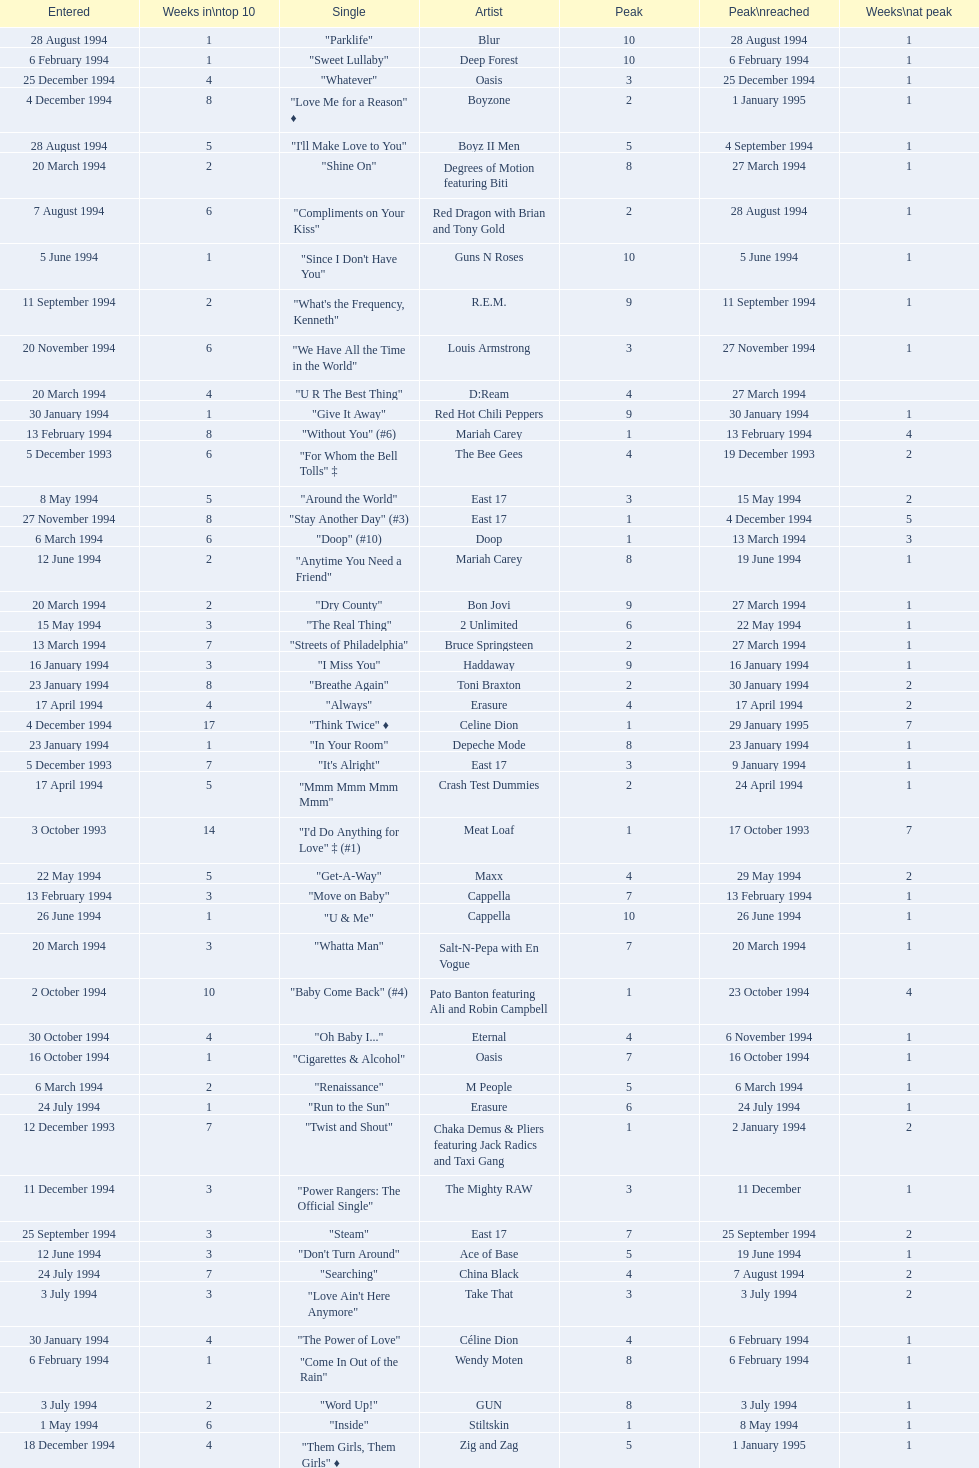Can you give me this table as a dict? {'header': ['Entered', 'Weeks in\\ntop 10', 'Single', 'Artist', 'Peak', 'Peak\\nreached', 'Weeks\\nat peak'], 'rows': [['28 August 1994', '1', '"Parklife"', 'Blur', '10', '28 August 1994', '1'], ['6 February 1994', '1', '"Sweet Lullaby"', 'Deep Forest', '10', '6 February 1994', '1'], ['25 December 1994', '4', '"Whatever"', 'Oasis', '3', '25 December 1994', '1'], ['4 December 1994', '8', '"Love Me for a Reason" ♦', 'Boyzone', '2', '1 January 1995', '1'], ['28 August 1994', '5', '"I\'ll Make Love to You"', 'Boyz II Men', '5', '4 September 1994', '1'], ['20 March 1994', '2', '"Shine On"', 'Degrees of Motion featuring Biti', '8', '27 March 1994', '1'], ['7 August 1994', '6', '"Compliments on Your Kiss"', 'Red Dragon with Brian and Tony Gold', '2', '28 August 1994', '1'], ['5 June 1994', '1', '"Since I Don\'t Have You"', 'Guns N Roses', '10', '5 June 1994', '1'], ['11 September 1994', '2', '"What\'s the Frequency, Kenneth"', 'R.E.M.', '9', '11 September 1994', '1'], ['20 November 1994', '6', '"We Have All the Time in the World"', 'Louis Armstrong', '3', '27 November 1994', '1'], ['20 March 1994', '4', '"U R The Best Thing"', 'D:Ream', '4', '27 March 1994', ''], ['30 January 1994', '1', '"Give It Away"', 'Red Hot Chili Peppers', '9', '30 January 1994', '1'], ['13 February 1994', '8', '"Without You" (#6)', 'Mariah Carey', '1', '13 February 1994', '4'], ['5 December 1993', '6', '"For Whom the Bell Tolls" ‡', 'The Bee Gees', '4', '19 December 1993', '2'], ['8 May 1994', '5', '"Around the World"', 'East 17', '3', '15 May 1994', '2'], ['27 November 1994', '8', '"Stay Another Day" (#3)', 'East 17', '1', '4 December 1994', '5'], ['6 March 1994', '6', '"Doop" (#10)', 'Doop', '1', '13 March 1994', '3'], ['12 June 1994', '2', '"Anytime You Need a Friend"', 'Mariah Carey', '8', '19 June 1994', '1'], ['20 March 1994', '2', '"Dry County"', 'Bon Jovi', '9', '27 March 1994', '1'], ['15 May 1994', '3', '"The Real Thing"', '2 Unlimited', '6', '22 May 1994', '1'], ['13 March 1994', '7', '"Streets of Philadelphia"', 'Bruce Springsteen', '2', '27 March 1994', '1'], ['16 January 1994', '3', '"I Miss You"', 'Haddaway', '9', '16 January 1994', '1'], ['23 January 1994', '8', '"Breathe Again"', 'Toni Braxton', '2', '30 January 1994', '2'], ['17 April 1994', '4', '"Always"', 'Erasure', '4', '17 April 1994', '2'], ['4 December 1994', '17', '"Think Twice" ♦', 'Celine Dion', '1', '29 January 1995', '7'], ['23 January 1994', '1', '"In Your Room"', 'Depeche Mode', '8', '23 January 1994', '1'], ['5 December 1993', '7', '"It\'s Alright"', 'East 17', '3', '9 January 1994', '1'], ['17 April 1994', '5', '"Mmm Mmm Mmm Mmm"', 'Crash Test Dummies', '2', '24 April 1994', '1'], ['3 October 1993', '14', '"I\'d Do Anything for Love" ‡ (#1)', 'Meat Loaf', '1', '17 October 1993', '7'], ['22 May 1994', '5', '"Get-A-Way"', 'Maxx', '4', '29 May 1994', '2'], ['13 February 1994', '3', '"Move on Baby"', 'Cappella', '7', '13 February 1994', '1'], ['26 June 1994', '1', '"U & Me"', 'Cappella', '10', '26 June 1994', '1'], ['20 March 1994', '3', '"Whatta Man"', 'Salt-N-Pepa with En Vogue', '7', '20 March 1994', '1'], ['2 October 1994', '10', '"Baby Come Back" (#4)', 'Pato Banton featuring Ali and Robin Campbell', '1', '23 October 1994', '4'], ['30 October 1994', '4', '"Oh Baby I..."', 'Eternal', '4', '6 November 1994', '1'], ['16 October 1994', '1', '"Cigarettes & Alcohol"', 'Oasis', '7', '16 October 1994', '1'], ['6 March 1994', '2', '"Renaissance"', 'M People', '5', '6 March 1994', '1'], ['24 July 1994', '1', '"Run to the Sun"', 'Erasure', '6', '24 July 1994', '1'], ['12 December 1993', '7', '"Twist and Shout"', 'Chaka Demus & Pliers featuring Jack Radics and Taxi Gang', '1', '2 January 1994', '2'], ['11 December 1994', '3', '"Power Rangers: The Official Single"', 'The Mighty RAW', '3', '11 December', '1'], ['25 September 1994', '3', '"Steam"', 'East 17', '7', '25 September 1994', '2'], ['12 June 1994', '3', '"Don\'t Turn Around"', 'Ace of Base', '5', '19 June 1994', '1'], ['24 July 1994', '7', '"Searching"', 'China Black', '4', '7 August 1994', '2'], ['3 July 1994', '3', '"Love Ain\'t Here Anymore"', 'Take That', '3', '3 July 1994', '2'], ['30 January 1994', '4', '"The Power of Love"', 'Céline Dion', '4', '6 February 1994', '1'], ['6 February 1994', '1', '"Come In Out of the Rain"', 'Wendy Moten', '8', '6 February 1994', '1'], ['3 July 1994', '2', '"Word Up!"', 'GUN', '8', '3 July 1994', '1'], ['1 May 1994', '6', '"Inside"', 'Stiltskin', '1', '8 May 1994', '1'], ['18 December 1994', '4', '"Them Girls, Them Girls" ♦', 'Zig and Zag', '5', '1 January 1995', '1'], ['16 October 1994', '4', '"Welcome to Tomorrow (Are You Ready?)"', 'Snap! featuring Summer', '6', '30 October 1994', '1'], ['10 July 1994', '9', '"Crazy for You" (#8)', 'Let Loose', '2', '14 August 1994', '2'], ['30 October 1994', '2', '"Some Girls"', 'Ultimate Kaos', '9', '30 October 1994', '1'], ['17 July 1994', '8', '"Regulate"', 'Warren G and Nate Dogg', '5', '24 July 1994', '1'], ['27 November 1994', '2', '"Love Spreads"', 'The Stone Roses', '2', '27 November 1994', '1'], ['12 December 1993', '5', '"The Perfect Year"', 'Dina Carroll', '5', '2 January 1994', '1'], ['18 December 1994', '10', '"Cotton Eye Joe" ♦', 'Rednex', '1', '8 January 1995', '3'], ['12 December 1993', '5', '"Babe" ‡', 'Take That', '1', '12 December 1993', '1'], ['28 November 1993', '7', '"Mr Blobby" ‡ (#6)', 'Mr Blobby', '1', '5 December 1993', '3'], ['31 July 1994', '4', '"Let\'s Get Ready to Rhumble"', 'PJ & Duncan', '1', '31 March 2013', '1'], ['16 October 1994', '5', '"She\'s Got That Vibe"', 'R. Kelly', '3', '6 November 1994', '1'], ['17 July 1994', '2', '"Everything is Alright (Uptight)"', 'C.J. Lewis', '10', '17 July 1994', '2'], ['5 June 1994', '3', '"Absolutely Fabulous"', 'Absolutely Fabulous', '6', '12 June 1994', '1'], ['9 January 1994', '4', '"Anything"', 'Culture Beat', '5', '9 January 1994', '2'], ['2 October 1994', '6', '"Sweetness"', 'Michelle Gayle', '4', '30 October 1994', '1'], ['27 February 1994', '1', '"Don\'t Go Breaking My Heart"', 'Elton John and RuPaul', '7', '27 February 1994', '1'], ['6 February 1994', '11', '"I Like to Move It"', 'Reel 2 Real featuring The Mad Stuntman', '5', '27 March 1994', '1'], ['13 March 1994', '1', '"Pretty Good Year"', 'Tori Amos', '7', '13 March 1994', '1'], ['2 October 1994', '2', '"Secret"', 'Madonna', '5', '2 October 1994', '1'], ['6 November 1994', '4', '"All I Wanna Do"', 'Sheryl Crow', '4', '20 November 1994', '1'], ['21 August 1994', '1', '"Eighteen Strings"', 'Tinman', '9', '21 August 1994', '1'], ['11 September 1994', '4', '"Endless Love"', 'Luther Vandross and Mariah Carey', '3', '11 September 1994', '2'], ['2 January 1994', '9', '"Things Can Only Get Better" (#9)', 'D:Ream', '1', '16 January 1994', '4'], ['24 April 1994', '1', '"I\'ll Stand by You"', 'The Pretenders', '10', '24 April 1994', '1'], ['20 February 1994', '9', '"The Sign"', 'Ace of Base', '2', '27 February 1994', '3'], ['11 December 1994', '2', '"Another Day" ♦', 'Whigfield', '7', '1 January 1995', '1'], ['18 September 1994', '11', '"Always" (#7)', 'Bon Jovi', '2', '2 October 1994', '3'], ['11 September 1994', '3', '"Incredible"', 'M-Beat featuring General Levy', '8', '18 September 1994', '1'], ['6 February 1994', '2', '"A Deeper Love"', 'Aretha Franklin featuring Lisa Fischer', '5', '6 February 1994', '1'], ['1 May 1994', '2', '"Light My Fire"', 'Clubhouse featuring Carl', '7', '1 May 1994', '1'], ['23 October 1994', '1', '"When We Dance"', 'Sting', '9', '23 October 1994', '1'], ['23 January 1994', '8', '"Return to Innocence"', 'Enigma', '3', '6 February 1994', '2'], ['20 February 1994', '2', '"Stay Together"', 'Suede', '3', '20 February 1994', '1'], ['12 June 1994', '8', '"Swamp Thing"', 'The Grid', '3', '26 June 1994', '1'], ['22 May 1994', '6', '"No Good (Start the Dance)"', 'The Prodigy', '4', '12 June 1994', '1'], ['27 March 1994', '3', '"I\'ll Remember"', 'Madonna', '7', '3 April 1994', '1'], ['26 December 1993', '7', '"Come Baby Come"', 'K7', '3', '16 January 1994', '2'], ['6 March 1994', '1', '"The More You Ignore Me, The Closer I Get"', 'Morrissey', '8', '6 March 1994', '1'], ['6 March 1994', '1', '"Rocks" / "Funky Jam"', 'Primal Scream', '7', '6 March 1994', '1'], ['19 December 1993', '3', '"Bat Out of Hell" ‡', 'Meat Loaf', '8', '19 December 1993', '2'], ['5 June 1994', '5', '"You Don\'t Love Me (No, No, No)"', 'Dawn Penn', '3', '12 June 1994', '2'], ['3 April 1994', '4', '"Everything Changes"', 'Take That', '1', '3 April 1994', '2'], ['4 September 1994', '3', '"Confide in Me"', 'Kylie Minogue', '2', '4 September 1994', '1'], ['16 January 1994', '1', '"Save Our Love"', 'Eternal', '8', '16 January 1994', '1'], ['11 December 1994', '2', '"Please Come Home for Christmas"', 'Bon Jovi', '7', '11 December 1994', '1'], ['9 January 1994', '8', '"All for Love"', 'Bryan Adams, Rod Stewart and Sting', '2', '23 January 1994', '1'], ['16 January 1994', '1', '"Here I Stand"', 'Bitty McLean', '10', '16 January 1994', '1'], ['14 August 1994', '2', '"Live Forever"', 'Oasis', '10', '14 August 1994', '2'], ['26 June 1994', '6', '"Shine"', 'Aswad', '5', '17 July 1994', '1'], ['7 August 1994', '4', '"What\'s Up?"', 'DJ Miko', '6', '14 August 1994', '1'], ['10 April 1994', '2', '"Rock My Heart"', 'Haddaway', '9', '10 April 1994', '2'], ['4 December 1994', '5', '"All I Want for Christmas Is You"', 'Mariah Carey', '2', '11 December 1994', '3'], ['13 November 1994', '1', '"True Faith \'94"', 'New Order', '9', '13 November 1994', '1'], ['13 March 1994', '2', '"Girls & Boys"', 'Blur', '5', '13 March 1994', '1'], ['24 April 1994', '6', '"Sweets for My Sweet"', 'C.J. Lewis', '3', '1 May 1994', '1'], ['17 April 1994', '3', '"Dedicated to the One I Love"', 'Bitty McLean', '6', '24 April 1994', '1'], ['25 September 1994', '6', '"Stay (I Missed You)"', 'Lisa Loeb and Nine Stories', '6', '25 September 1994', '1'], ['31 July 1994', '2', '"No More (I Can\'t Stand It)"', 'Maxx', '8', '7 August 1994', '1'], ['10 April 1994', '6', '"The Real Thing"', 'Tony Di Bart', '1', '1 May 1994', '1'], ['10 July 1994', '2', '"Everybody Gonfi-Gon"', '2 Cowboys', '7', '10 July 1994', '1'], ['3 April 1994', '6', '"The Most Beautiful Girl in the World"', 'Prince', '1', '17 April 1994', '2'], ['26 June 1994', '2', '"Go On Move"', 'Reel 2 Real featuring The Mad Stuntman', '7', '26 June 1994', '2'], ['6 November 1994', '5', '"Another Night"', 'MC Sar and Real McCoy', '2', '13 November 1994', '1'], ['11 September 1994', '10', '"Saturday Night" (#2)', 'Whigfield', '1', '11 September 1994', '4'], ['15 May 1994', '20', '"Love Is All Around" (#1)', 'Wet Wet Wet', '1', '29 May 1994', '15'], ['15 May 1994', '2', '"More to This World"', 'Bad Boys Inc', '8', '22 May 1994', '1'], ['25 September 1994', '6', '"Hey Now (Girls Just Want to Have Fun)"', 'Cyndi Lauper', '4', '2 October 1994', '1'], ['9 October 1994', '3', '"Sure"', 'Take That', '1', '9 October 1994', '2'], ['4 September 1994', '6', '"The Rhythm of the Night"', 'Corona', '2', '18 September 1994', '2'], ['29 May 1994', '7', '"Baby, I Love Your Way"', 'Big Mountain', '2', '5 June 1994', '3'], ['14 August 1994', '6', '"7 Seconds"', "Youssou N'Dour featuring Neneh Cherry", '3', '4 September 1994', '1'], ['1 May 1994', '7', '"Come on You Reds"', 'Manchester United Football Squad featuring Status Quo', '1', '15 May 1994', '2'], ['3 July 1994', '7', '"(Meet) The Flintstones"', 'The B.C. 52s', '3', '17 July 1994', '3'], ['8 May 1994', '3', '"Just a Step from Heaven"', 'Eternal', '8', '15 May 1994', '1'], ['29 May 1994', '1', '"Carry Me Home"', 'Gloworm', '9', '29 May 1994', '1'], ['20 November 1994', '1', '"Spin the Black Circle"', 'Pearl Jam', '10', '20 November 1994', '1'], ['13 November 1994', '5', '"Let Me Be Your Fantasy"', 'Baby D', '1', '20 November 1994', '2'], ['20 November 1994', '7', '"Crocodile Shoes"', 'Jimmy Nail', '4', '4 December 1994', '1'], ['16 January 1994', '3', '"Cornflake Girl"', 'Tori Amos', '4', '23 January 1994', '1'], ['13 November 1994', '3', '"Sight for Sore Eyes"', 'M People', '6', '20 November 1994', '1'], ['19 June 1994', '12', '"I Swear" (#5)', 'All-4-One', '2', '26 June 1994', '7'], ['13 February 1994', '4', '"Let the Beat Control Your Body"', '2 Unlimited', '6', '27 February 1994', '1']]} What is the first entered date? 3 October 1993. 